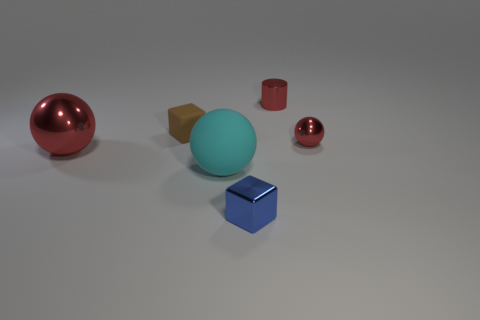What color is the cube that is in front of the block behind the tiny shiny block?
Offer a terse response. Blue. What is the size of the red shiny thing that is in front of the tiny brown thing and to the right of the big red metallic thing?
Offer a terse response. Small. Is there any other thing that is the same color as the small metallic cylinder?
Offer a very short reply. Yes. What shape is the big red object that is made of the same material as the small blue block?
Ensure brevity in your answer.  Sphere. There is a big red metal thing; is it the same shape as the metallic object that is to the right of the cylinder?
Your answer should be compact. Yes. The red ball to the left of the sphere right of the blue thing is made of what material?
Offer a terse response. Metal. Is the number of large rubber balls behind the big matte object the same as the number of small gray spheres?
Offer a terse response. Yes. Does the metal thing that is left of the matte ball have the same color as the small thing behind the tiny rubber cube?
Provide a succinct answer. Yes. How many spheres are to the left of the red metallic cylinder and behind the cyan ball?
Offer a very short reply. 1. How many other things are there of the same shape as the small blue object?
Keep it short and to the point. 1. 